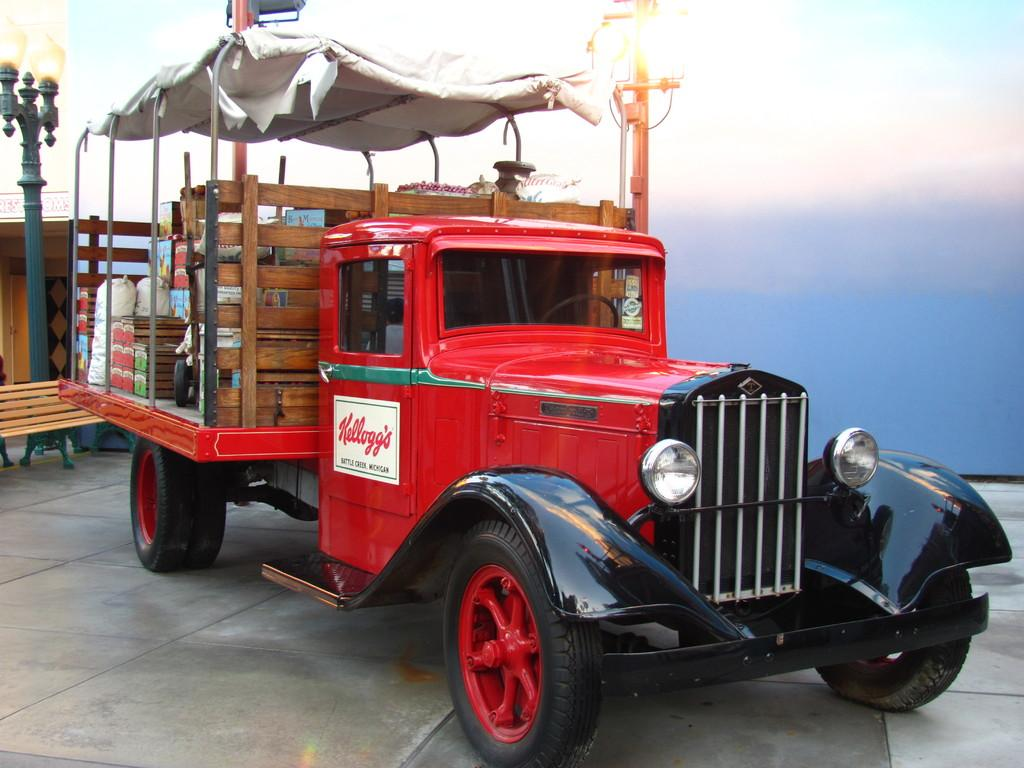What type of vehicle is in the image? There is a red color vehicle in the image. Where is the vehicle located? The vehicle is on the floor. What can be seen in the background of the image? There is a pole, a bench, and a building in the background of the image. What is visible at the top of the image? The sky is visible at the top of the image. How many cats are playing on the channel in the image? There are no cats or channels present in the image. 